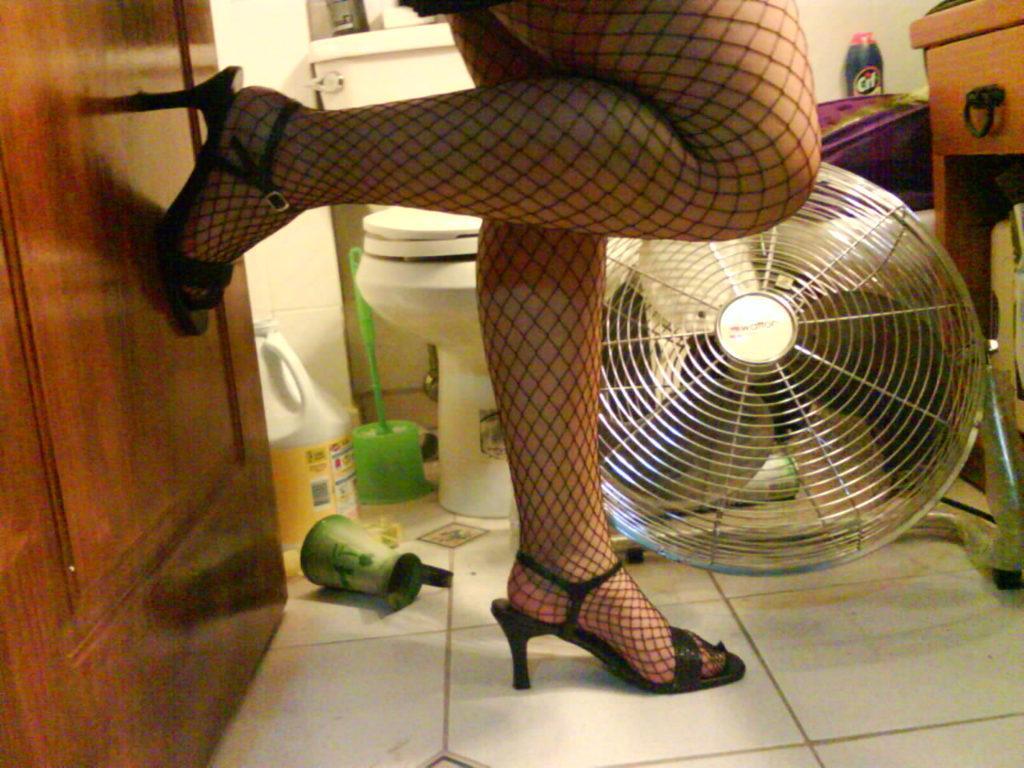Describe this image in one or two sentences. In this image I can see the person with the footwear. To the side of the person I can see the table-fan, can and many objects on the floor. In the background I can see the toilet and few objects on the shelf. To the right I can see the wooden object. 